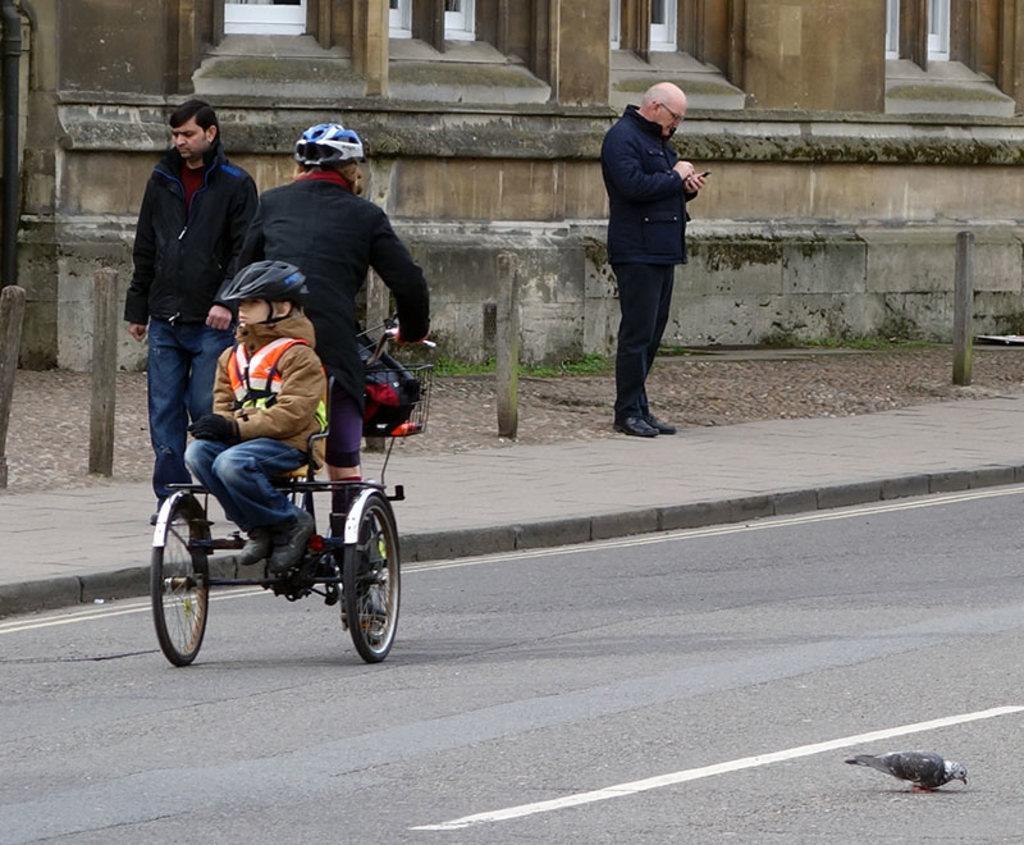In one or two sentences, can you explain what this image depicts? This picture is clicked on a road. To the left corner of the image there is a man walking on a walk way. On the road there is man riding bicycle and a boy is sitting behind him. They both are wearing jackets and helmets. There is another man standing on the walkway and looking at his mobile phone. To the below right corner of the image there is bird on the road. In the background there is a building and grass. 